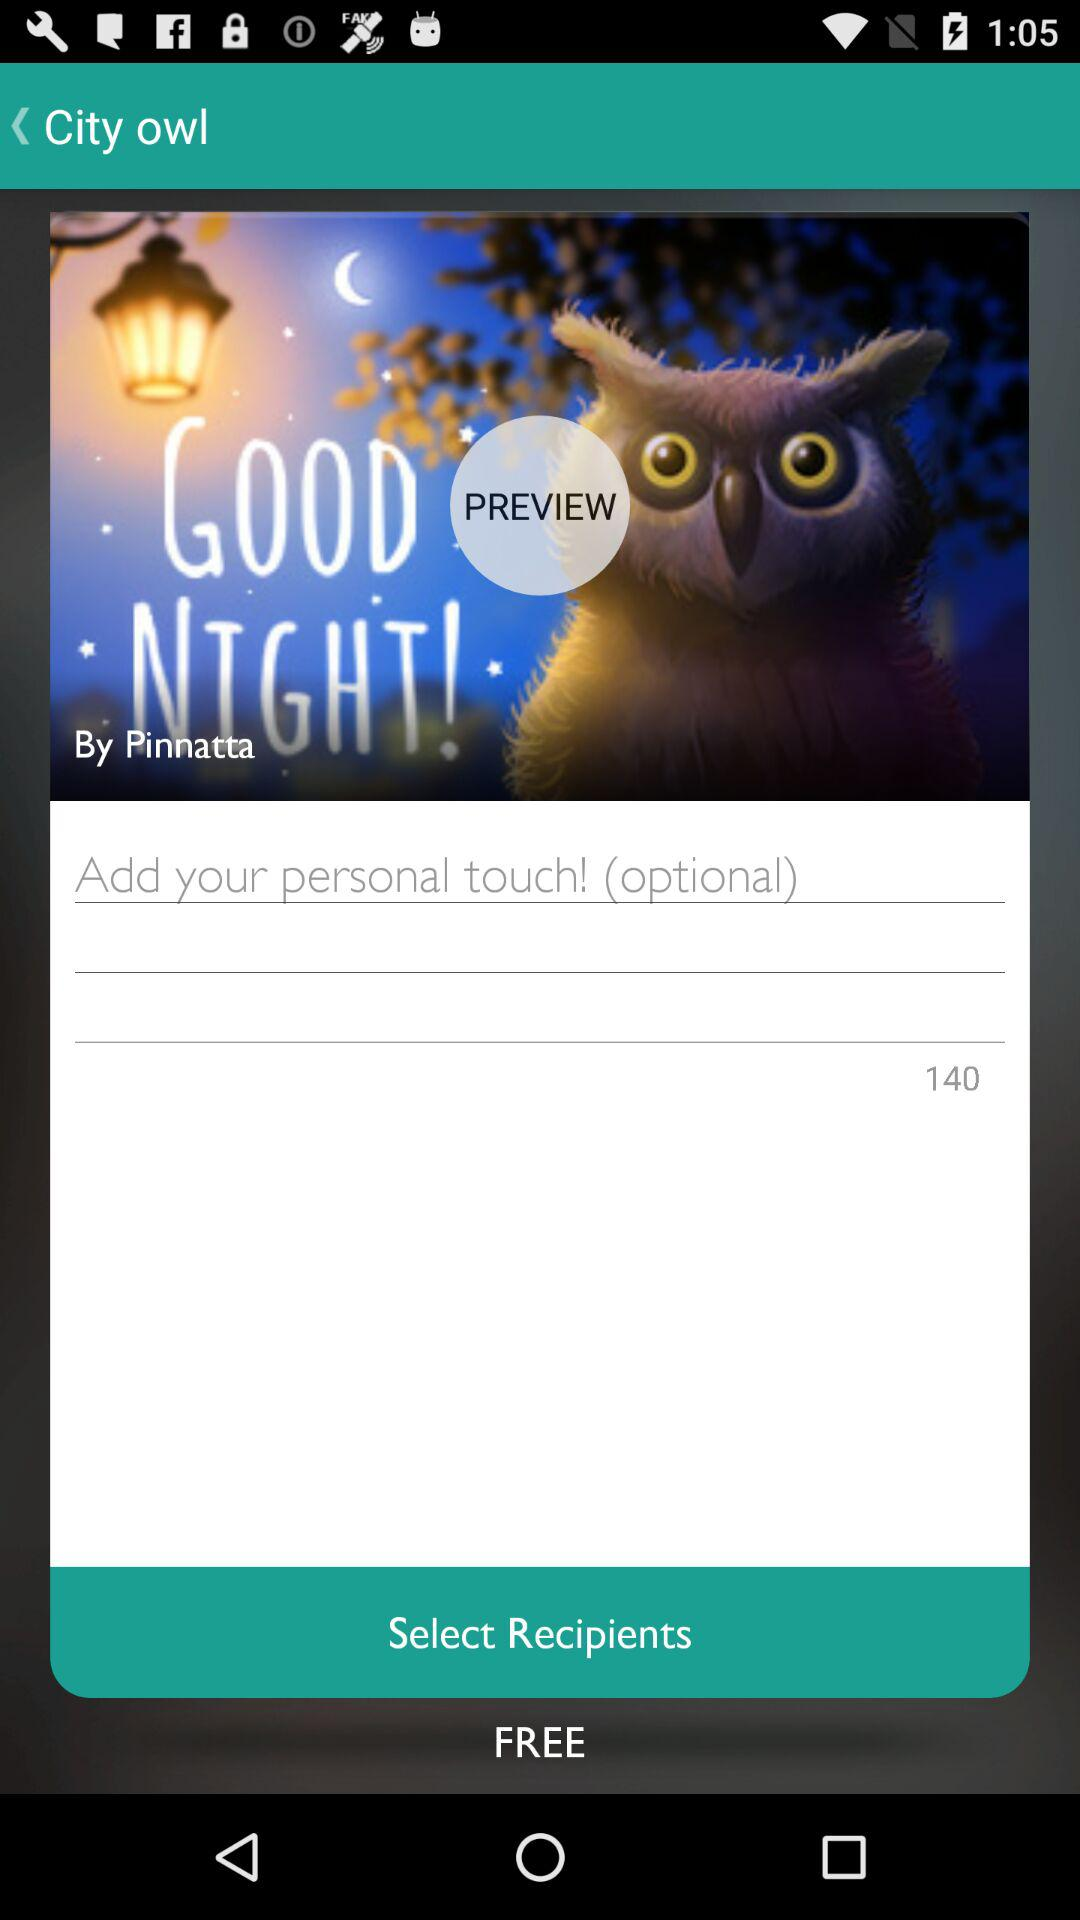What's the given price? The price is "FREE". 